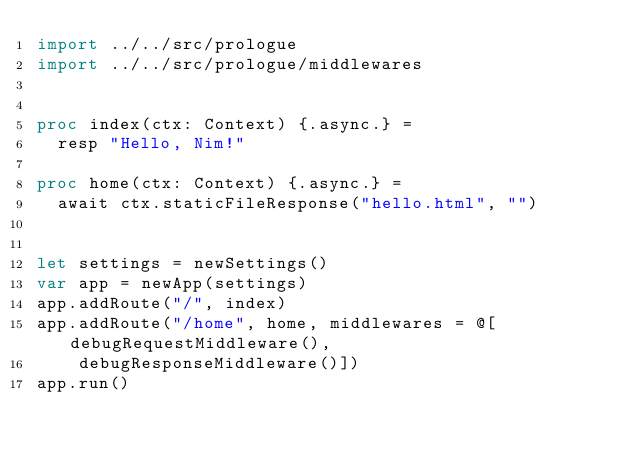Convert code to text. <code><loc_0><loc_0><loc_500><loc_500><_Nim_>import ../../src/prologue
import ../../src/prologue/middlewares


proc index(ctx: Context) {.async.} =
  resp "Hello, Nim!"

proc home(ctx: Context) {.async.} =
  await ctx.staticFileResponse("hello.html", "")


let settings = newSettings()
var app = newApp(settings)
app.addRoute("/", index)
app.addRoute("/home", home, middlewares = @[debugRequestMiddleware(),
    debugResponseMiddleware()])
app.run()
</code> 